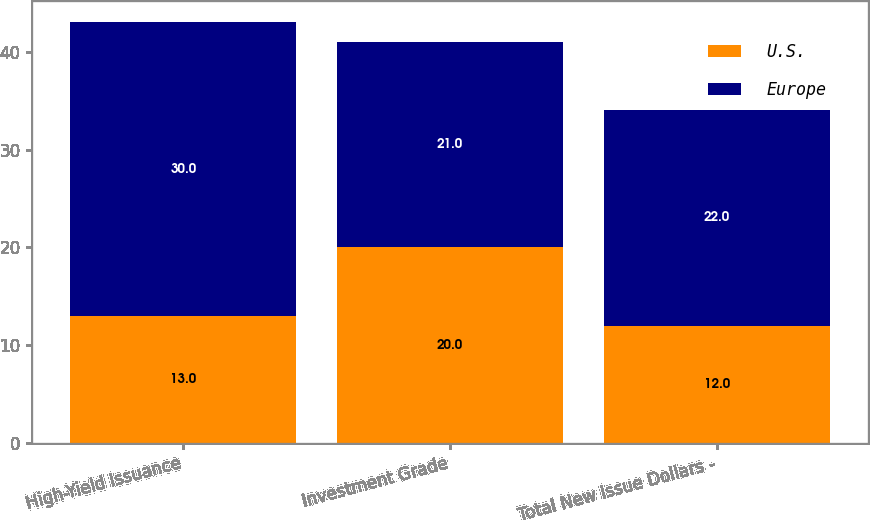Convert chart to OTSL. <chart><loc_0><loc_0><loc_500><loc_500><stacked_bar_chart><ecel><fcel>High-Yield Issuance<fcel>Investment Grade<fcel>Total New Issue Dollars -<nl><fcel>U.S.<fcel>13<fcel>20<fcel>12<nl><fcel>Europe<fcel>30<fcel>21<fcel>22<nl></chart> 